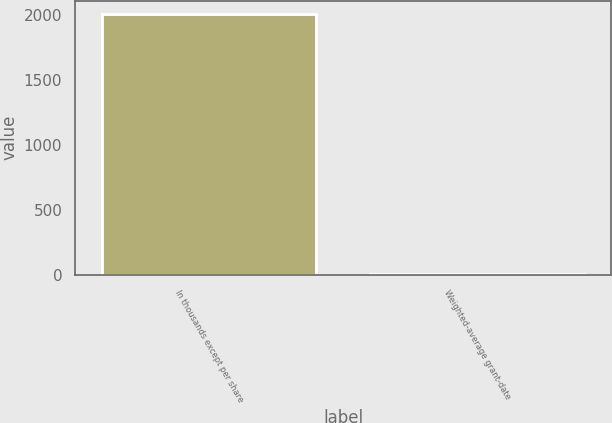Convert chart to OTSL. <chart><loc_0><loc_0><loc_500><loc_500><bar_chart><fcel>In thousands except per share<fcel>Weighted-average grant-date<nl><fcel>2008<fcel>9.84<nl></chart> 